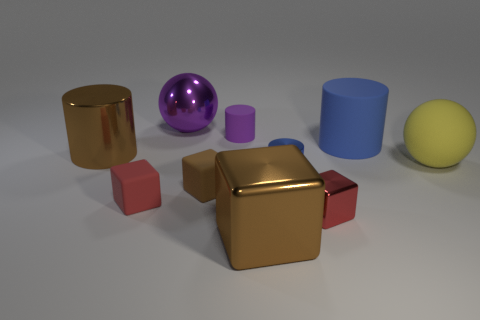Subtract 1 cylinders. How many cylinders are left? 3 Subtract all cubes. How many objects are left? 6 Subtract all tiny brown rubber things. Subtract all shiny things. How many objects are left? 4 Add 3 small rubber blocks. How many small rubber blocks are left? 5 Add 8 red shiny blocks. How many red shiny blocks exist? 9 Subtract 0 gray cubes. How many objects are left? 10 